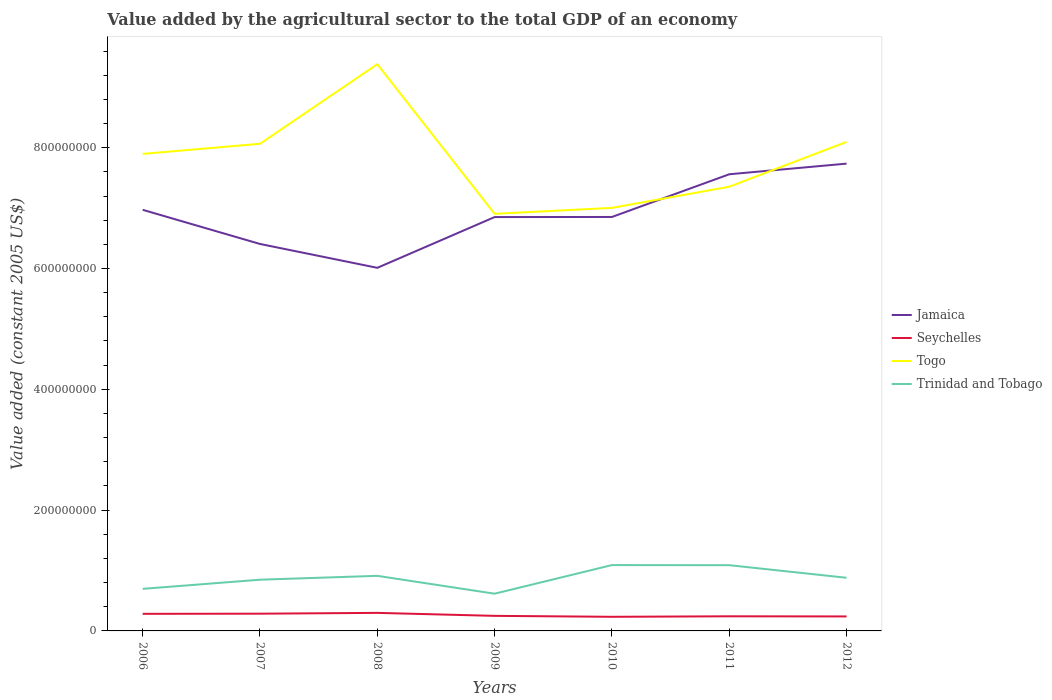How many different coloured lines are there?
Your answer should be very brief. 4. Does the line corresponding to Seychelles intersect with the line corresponding to Jamaica?
Your response must be concise. No. Across all years, what is the maximum value added by the agricultural sector in Trinidad and Tobago?
Your answer should be compact. 6.16e+07. What is the total value added by the agricultural sector in Togo in the graph?
Provide a short and direct response. -1.19e+08. What is the difference between the highest and the second highest value added by the agricultural sector in Jamaica?
Your answer should be very brief. 1.72e+08. What is the difference between the highest and the lowest value added by the agricultural sector in Togo?
Your answer should be very brief. 4. How many lines are there?
Keep it short and to the point. 4. Are the values on the major ticks of Y-axis written in scientific E-notation?
Give a very brief answer. No. Does the graph contain any zero values?
Keep it short and to the point. No. Does the graph contain grids?
Offer a very short reply. No. What is the title of the graph?
Provide a succinct answer. Value added by the agricultural sector to the total GDP of an economy. What is the label or title of the X-axis?
Provide a succinct answer. Years. What is the label or title of the Y-axis?
Your answer should be compact. Value added (constant 2005 US$). What is the Value added (constant 2005 US$) of Jamaica in 2006?
Your answer should be very brief. 6.97e+08. What is the Value added (constant 2005 US$) of Seychelles in 2006?
Offer a terse response. 2.83e+07. What is the Value added (constant 2005 US$) of Togo in 2006?
Your answer should be compact. 7.90e+08. What is the Value added (constant 2005 US$) of Trinidad and Tobago in 2006?
Keep it short and to the point. 6.96e+07. What is the Value added (constant 2005 US$) in Jamaica in 2007?
Give a very brief answer. 6.41e+08. What is the Value added (constant 2005 US$) in Seychelles in 2007?
Your answer should be compact. 2.85e+07. What is the Value added (constant 2005 US$) in Togo in 2007?
Your answer should be very brief. 8.06e+08. What is the Value added (constant 2005 US$) in Trinidad and Tobago in 2007?
Offer a terse response. 8.48e+07. What is the Value added (constant 2005 US$) in Jamaica in 2008?
Provide a short and direct response. 6.01e+08. What is the Value added (constant 2005 US$) in Seychelles in 2008?
Give a very brief answer. 2.99e+07. What is the Value added (constant 2005 US$) in Togo in 2008?
Your response must be concise. 9.38e+08. What is the Value added (constant 2005 US$) in Trinidad and Tobago in 2008?
Your response must be concise. 9.12e+07. What is the Value added (constant 2005 US$) in Jamaica in 2009?
Your response must be concise. 6.85e+08. What is the Value added (constant 2005 US$) of Seychelles in 2009?
Provide a succinct answer. 2.49e+07. What is the Value added (constant 2005 US$) of Togo in 2009?
Your answer should be compact. 6.91e+08. What is the Value added (constant 2005 US$) of Trinidad and Tobago in 2009?
Keep it short and to the point. 6.16e+07. What is the Value added (constant 2005 US$) of Jamaica in 2010?
Your answer should be very brief. 6.85e+08. What is the Value added (constant 2005 US$) in Seychelles in 2010?
Provide a short and direct response. 2.34e+07. What is the Value added (constant 2005 US$) of Togo in 2010?
Your answer should be very brief. 7.00e+08. What is the Value added (constant 2005 US$) of Trinidad and Tobago in 2010?
Your answer should be compact. 1.09e+08. What is the Value added (constant 2005 US$) of Jamaica in 2011?
Your answer should be compact. 7.56e+08. What is the Value added (constant 2005 US$) of Seychelles in 2011?
Your answer should be compact. 2.42e+07. What is the Value added (constant 2005 US$) of Togo in 2011?
Your answer should be compact. 7.35e+08. What is the Value added (constant 2005 US$) in Trinidad and Tobago in 2011?
Your response must be concise. 1.09e+08. What is the Value added (constant 2005 US$) of Jamaica in 2012?
Provide a succinct answer. 7.74e+08. What is the Value added (constant 2005 US$) of Seychelles in 2012?
Provide a short and direct response. 2.40e+07. What is the Value added (constant 2005 US$) in Togo in 2012?
Keep it short and to the point. 8.10e+08. What is the Value added (constant 2005 US$) of Trinidad and Tobago in 2012?
Your answer should be very brief. 8.80e+07. Across all years, what is the maximum Value added (constant 2005 US$) in Jamaica?
Offer a very short reply. 7.74e+08. Across all years, what is the maximum Value added (constant 2005 US$) of Seychelles?
Keep it short and to the point. 2.99e+07. Across all years, what is the maximum Value added (constant 2005 US$) in Togo?
Ensure brevity in your answer.  9.38e+08. Across all years, what is the maximum Value added (constant 2005 US$) of Trinidad and Tobago?
Provide a short and direct response. 1.09e+08. Across all years, what is the minimum Value added (constant 2005 US$) of Jamaica?
Give a very brief answer. 6.01e+08. Across all years, what is the minimum Value added (constant 2005 US$) of Seychelles?
Offer a terse response. 2.34e+07. Across all years, what is the minimum Value added (constant 2005 US$) in Togo?
Offer a very short reply. 6.91e+08. Across all years, what is the minimum Value added (constant 2005 US$) in Trinidad and Tobago?
Provide a succinct answer. 6.16e+07. What is the total Value added (constant 2005 US$) in Jamaica in the graph?
Provide a short and direct response. 4.84e+09. What is the total Value added (constant 2005 US$) of Seychelles in the graph?
Offer a very short reply. 1.83e+08. What is the total Value added (constant 2005 US$) in Togo in the graph?
Provide a succinct answer. 5.47e+09. What is the total Value added (constant 2005 US$) in Trinidad and Tobago in the graph?
Your response must be concise. 6.13e+08. What is the difference between the Value added (constant 2005 US$) of Jamaica in 2006 and that in 2007?
Make the answer very short. 5.65e+07. What is the difference between the Value added (constant 2005 US$) of Seychelles in 2006 and that in 2007?
Offer a terse response. -2.33e+05. What is the difference between the Value added (constant 2005 US$) in Togo in 2006 and that in 2007?
Your response must be concise. -1.67e+07. What is the difference between the Value added (constant 2005 US$) of Trinidad and Tobago in 2006 and that in 2007?
Provide a succinct answer. -1.51e+07. What is the difference between the Value added (constant 2005 US$) in Jamaica in 2006 and that in 2008?
Make the answer very short. 9.60e+07. What is the difference between the Value added (constant 2005 US$) of Seychelles in 2006 and that in 2008?
Keep it short and to the point. -1.56e+06. What is the difference between the Value added (constant 2005 US$) of Togo in 2006 and that in 2008?
Give a very brief answer. -1.49e+08. What is the difference between the Value added (constant 2005 US$) in Trinidad and Tobago in 2006 and that in 2008?
Provide a short and direct response. -2.16e+07. What is the difference between the Value added (constant 2005 US$) of Jamaica in 2006 and that in 2009?
Make the answer very short. 1.20e+07. What is the difference between the Value added (constant 2005 US$) in Seychelles in 2006 and that in 2009?
Your answer should be very brief. 3.37e+06. What is the difference between the Value added (constant 2005 US$) in Togo in 2006 and that in 2009?
Offer a very short reply. 9.92e+07. What is the difference between the Value added (constant 2005 US$) of Trinidad and Tobago in 2006 and that in 2009?
Offer a terse response. 8.02e+06. What is the difference between the Value added (constant 2005 US$) in Jamaica in 2006 and that in 2010?
Give a very brief answer. 1.18e+07. What is the difference between the Value added (constant 2005 US$) of Seychelles in 2006 and that in 2010?
Keep it short and to the point. 4.92e+06. What is the difference between the Value added (constant 2005 US$) of Togo in 2006 and that in 2010?
Make the answer very short. 8.94e+07. What is the difference between the Value added (constant 2005 US$) of Trinidad and Tobago in 2006 and that in 2010?
Give a very brief answer. -3.94e+07. What is the difference between the Value added (constant 2005 US$) of Jamaica in 2006 and that in 2011?
Provide a succinct answer. -5.89e+07. What is the difference between the Value added (constant 2005 US$) in Seychelles in 2006 and that in 2011?
Ensure brevity in your answer.  4.10e+06. What is the difference between the Value added (constant 2005 US$) of Togo in 2006 and that in 2011?
Keep it short and to the point. 5.44e+07. What is the difference between the Value added (constant 2005 US$) in Trinidad and Tobago in 2006 and that in 2011?
Keep it short and to the point. -3.92e+07. What is the difference between the Value added (constant 2005 US$) of Jamaica in 2006 and that in 2012?
Make the answer very short. -7.65e+07. What is the difference between the Value added (constant 2005 US$) in Seychelles in 2006 and that in 2012?
Provide a succinct answer. 4.33e+06. What is the difference between the Value added (constant 2005 US$) in Togo in 2006 and that in 2012?
Your response must be concise. -1.98e+07. What is the difference between the Value added (constant 2005 US$) in Trinidad and Tobago in 2006 and that in 2012?
Make the answer very short. -1.83e+07. What is the difference between the Value added (constant 2005 US$) of Jamaica in 2007 and that in 2008?
Provide a short and direct response. 3.95e+07. What is the difference between the Value added (constant 2005 US$) in Seychelles in 2007 and that in 2008?
Make the answer very short. -1.33e+06. What is the difference between the Value added (constant 2005 US$) in Togo in 2007 and that in 2008?
Offer a very short reply. -1.32e+08. What is the difference between the Value added (constant 2005 US$) in Trinidad and Tobago in 2007 and that in 2008?
Offer a terse response. -6.41e+06. What is the difference between the Value added (constant 2005 US$) of Jamaica in 2007 and that in 2009?
Provide a short and direct response. -4.45e+07. What is the difference between the Value added (constant 2005 US$) of Seychelles in 2007 and that in 2009?
Keep it short and to the point. 3.60e+06. What is the difference between the Value added (constant 2005 US$) in Togo in 2007 and that in 2009?
Your answer should be compact. 1.16e+08. What is the difference between the Value added (constant 2005 US$) of Trinidad and Tobago in 2007 and that in 2009?
Keep it short and to the point. 2.32e+07. What is the difference between the Value added (constant 2005 US$) of Jamaica in 2007 and that in 2010?
Your answer should be very brief. -4.47e+07. What is the difference between the Value added (constant 2005 US$) of Seychelles in 2007 and that in 2010?
Keep it short and to the point. 5.15e+06. What is the difference between the Value added (constant 2005 US$) in Togo in 2007 and that in 2010?
Offer a terse response. 1.06e+08. What is the difference between the Value added (constant 2005 US$) of Trinidad and Tobago in 2007 and that in 2010?
Your answer should be compact. -2.42e+07. What is the difference between the Value added (constant 2005 US$) in Jamaica in 2007 and that in 2011?
Provide a succinct answer. -1.15e+08. What is the difference between the Value added (constant 2005 US$) of Seychelles in 2007 and that in 2011?
Offer a very short reply. 4.33e+06. What is the difference between the Value added (constant 2005 US$) in Togo in 2007 and that in 2011?
Provide a succinct answer. 7.11e+07. What is the difference between the Value added (constant 2005 US$) of Trinidad and Tobago in 2007 and that in 2011?
Provide a succinct answer. -2.40e+07. What is the difference between the Value added (constant 2005 US$) of Jamaica in 2007 and that in 2012?
Provide a short and direct response. -1.33e+08. What is the difference between the Value added (constant 2005 US$) of Seychelles in 2007 and that in 2012?
Ensure brevity in your answer.  4.57e+06. What is the difference between the Value added (constant 2005 US$) of Togo in 2007 and that in 2012?
Provide a short and direct response. -3.08e+06. What is the difference between the Value added (constant 2005 US$) of Trinidad and Tobago in 2007 and that in 2012?
Ensure brevity in your answer.  -3.21e+06. What is the difference between the Value added (constant 2005 US$) of Jamaica in 2008 and that in 2009?
Provide a succinct answer. -8.40e+07. What is the difference between the Value added (constant 2005 US$) in Seychelles in 2008 and that in 2009?
Provide a succinct answer. 4.93e+06. What is the difference between the Value added (constant 2005 US$) in Togo in 2008 and that in 2009?
Provide a succinct answer. 2.48e+08. What is the difference between the Value added (constant 2005 US$) of Trinidad and Tobago in 2008 and that in 2009?
Provide a succinct answer. 2.96e+07. What is the difference between the Value added (constant 2005 US$) in Jamaica in 2008 and that in 2010?
Offer a terse response. -8.42e+07. What is the difference between the Value added (constant 2005 US$) of Seychelles in 2008 and that in 2010?
Make the answer very short. 6.48e+06. What is the difference between the Value added (constant 2005 US$) of Togo in 2008 and that in 2010?
Provide a short and direct response. 2.38e+08. What is the difference between the Value added (constant 2005 US$) of Trinidad and Tobago in 2008 and that in 2010?
Keep it short and to the point. -1.78e+07. What is the difference between the Value added (constant 2005 US$) in Jamaica in 2008 and that in 2011?
Keep it short and to the point. -1.55e+08. What is the difference between the Value added (constant 2005 US$) of Seychelles in 2008 and that in 2011?
Make the answer very short. 5.66e+06. What is the difference between the Value added (constant 2005 US$) of Togo in 2008 and that in 2011?
Keep it short and to the point. 2.03e+08. What is the difference between the Value added (constant 2005 US$) in Trinidad and Tobago in 2008 and that in 2011?
Make the answer very short. -1.76e+07. What is the difference between the Value added (constant 2005 US$) of Jamaica in 2008 and that in 2012?
Provide a succinct answer. -1.72e+08. What is the difference between the Value added (constant 2005 US$) of Seychelles in 2008 and that in 2012?
Provide a short and direct response. 5.89e+06. What is the difference between the Value added (constant 2005 US$) in Togo in 2008 and that in 2012?
Your answer should be very brief. 1.29e+08. What is the difference between the Value added (constant 2005 US$) in Trinidad and Tobago in 2008 and that in 2012?
Your answer should be compact. 3.21e+06. What is the difference between the Value added (constant 2005 US$) of Jamaica in 2009 and that in 2010?
Your answer should be very brief. -1.57e+05. What is the difference between the Value added (constant 2005 US$) in Seychelles in 2009 and that in 2010?
Give a very brief answer. 1.55e+06. What is the difference between the Value added (constant 2005 US$) in Togo in 2009 and that in 2010?
Offer a terse response. -9.86e+06. What is the difference between the Value added (constant 2005 US$) of Trinidad and Tobago in 2009 and that in 2010?
Offer a very short reply. -4.74e+07. What is the difference between the Value added (constant 2005 US$) in Jamaica in 2009 and that in 2011?
Offer a very short reply. -7.09e+07. What is the difference between the Value added (constant 2005 US$) of Seychelles in 2009 and that in 2011?
Make the answer very short. 7.29e+05. What is the difference between the Value added (constant 2005 US$) of Togo in 2009 and that in 2011?
Keep it short and to the point. -4.48e+07. What is the difference between the Value added (constant 2005 US$) of Trinidad and Tobago in 2009 and that in 2011?
Provide a succinct answer. -4.72e+07. What is the difference between the Value added (constant 2005 US$) in Jamaica in 2009 and that in 2012?
Provide a succinct answer. -8.85e+07. What is the difference between the Value added (constant 2005 US$) in Seychelles in 2009 and that in 2012?
Ensure brevity in your answer.  9.67e+05. What is the difference between the Value added (constant 2005 US$) of Togo in 2009 and that in 2012?
Provide a succinct answer. -1.19e+08. What is the difference between the Value added (constant 2005 US$) in Trinidad and Tobago in 2009 and that in 2012?
Provide a succinct answer. -2.64e+07. What is the difference between the Value added (constant 2005 US$) in Jamaica in 2010 and that in 2011?
Your answer should be compact. -7.07e+07. What is the difference between the Value added (constant 2005 US$) of Seychelles in 2010 and that in 2011?
Offer a terse response. -8.21e+05. What is the difference between the Value added (constant 2005 US$) in Togo in 2010 and that in 2011?
Your answer should be very brief. -3.50e+07. What is the difference between the Value added (constant 2005 US$) in Trinidad and Tobago in 2010 and that in 2011?
Make the answer very short. 1.78e+05. What is the difference between the Value added (constant 2005 US$) of Jamaica in 2010 and that in 2012?
Offer a terse response. -8.83e+07. What is the difference between the Value added (constant 2005 US$) of Seychelles in 2010 and that in 2012?
Give a very brief answer. -5.84e+05. What is the difference between the Value added (constant 2005 US$) in Togo in 2010 and that in 2012?
Provide a short and direct response. -1.09e+08. What is the difference between the Value added (constant 2005 US$) of Trinidad and Tobago in 2010 and that in 2012?
Your response must be concise. 2.10e+07. What is the difference between the Value added (constant 2005 US$) of Jamaica in 2011 and that in 2012?
Ensure brevity in your answer.  -1.76e+07. What is the difference between the Value added (constant 2005 US$) in Seychelles in 2011 and that in 2012?
Keep it short and to the point. 2.37e+05. What is the difference between the Value added (constant 2005 US$) of Togo in 2011 and that in 2012?
Your answer should be very brief. -7.42e+07. What is the difference between the Value added (constant 2005 US$) of Trinidad and Tobago in 2011 and that in 2012?
Make the answer very short. 2.08e+07. What is the difference between the Value added (constant 2005 US$) in Jamaica in 2006 and the Value added (constant 2005 US$) in Seychelles in 2007?
Make the answer very short. 6.69e+08. What is the difference between the Value added (constant 2005 US$) in Jamaica in 2006 and the Value added (constant 2005 US$) in Togo in 2007?
Ensure brevity in your answer.  -1.09e+08. What is the difference between the Value added (constant 2005 US$) in Jamaica in 2006 and the Value added (constant 2005 US$) in Trinidad and Tobago in 2007?
Offer a terse response. 6.12e+08. What is the difference between the Value added (constant 2005 US$) in Seychelles in 2006 and the Value added (constant 2005 US$) in Togo in 2007?
Make the answer very short. -7.78e+08. What is the difference between the Value added (constant 2005 US$) of Seychelles in 2006 and the Value added (constant 2005 US$) of Trinidad and Tobago in 2007?
Ensure brevity in your answer.  -5.65e+07. What is the difference between the Value added (constant 2005 US$) in Togo in 2006 and the Value added (constant 2005 US$) in Trinidad and Tobago in 2007?
Your answer should be compact. 7.05e+08. What is the difference between the Value added (constant 2005 US$) of Jamaica in 2006 and the Value added (constant 2005 US$) of Seychelles in 2008?
Your answer should be compact. 6.67e+08. What is the difference between the Value added (constant 2005 US$) of Jamaica in 2006 and the Value added (constant 2005 US$) of Togo in 2008?
Provide a succinct answer. -2.41e+08. What is the difference between the Value added (constant 2005 US$) in Jamaica in 2006 and the Value added (constant 2005 US$) in Trinidad and Tobago in 2008?
Provide a short and direct response. 6.06e+08. What is the difference between the Value added (constant 2005 US$) of Seychelles in 2006 and the Value added (constant 2005 US$) of Togo in 2008?
Your answer should be very brief. -9.10e+08. What is the difference between the Value added (constant 2005 US$) in Seychelles in 2006 and the Value added (constant 2005 US$) in Trinidad and Tobago in 2008?
Provide a short and direct response. -6.29e+07. What is the difference between the Value added (constant 2005 US$) in Togo in 2006 and the Value added (constant 2005 US$) in Trinidad and Tobago in 2008?
Ensure brevity in your answer.  6.99e+08. What is the difference between the Value added (constant 2005 US$) in Jamaica in 2006 and the Value added (constant 2005 US$) in Seychelles in 2009?
Your response must be concise. 6.72e+08. What is the difference between the Value added (constant 2005 US$) of Jamaica in 2006 and the Value added (constant 2005 US$) of Togo in 2009?
Provide a short and direct response. 6.63e+06. What is the difference between the Value added (constant 2005 US$) in Jamaica in 2006 and the Value added (constant 2005 US$) in Trinidad and Tobago in 2009?
Your response must be concise. 6.36e+08. What is the difference between the Value added (constant 2005 US$) in Seychelles in 2006 and the Value added (constant 2005 US$) in Togo in 2009?
Keep it short and to the point. -6.62e+08. What is the difference between the Value added (constant 2005 US$) of Seychelles in 2006 and the Value added (constant 2005 US$) of Trinidad and Tobago in 2009?
Your response must be concise. -3.33e+07. What is the difference between the Value added (constant 2005 US$) in Togo in 2006 and the Value added (constant 2005 US$) in Trinidad and Tobago in 2009?
Your answer should be very brief. 7.28e+08. What is the difference between the Value added (constant 2005 US$) of Jamaica in 2006 and the Value added (constant 2005 US$) of Seychelles in 2010?
Give a very brief answer. 6.74e+08. What is the difference between the Value added (constant 2005 US$) in Jamaica in 2006 and the Value added (constant 2005 US$) in Togo in 2010?
Your response must be concise. -3.22e+06. What is the difference between the Value added (constant 2005 US$) of Jamaica in 2006 and the Value added (constant 2005 US$) of Trinidad and Tobago in 2010?
Your answer should be very brief. 5.88e+08. What is the difference between the Value added (constant 2005 US$) of Seychelles in 2006 and the Value added (constant 2005 US$) of Togo in 2010?
Ensure brevity in your answer.  -6.72e+08. What is the difference between the Value added (constant 2005 US$) in Seychelles in 2006 and the Value added (constant 2005 US$) in Trinidad and Tobago in 2010?
Provide a short and direct response. -8.07e+07. What is the difference between the Value added (constant 2005 US$) of Togo in 2006 and the Value added (constant 2005 US$) of Trinidad and Tobago in 2010?
Offer a terse response. 6.81e+08. What is the difference between the Value added (constant 2005 US$) in Jamaica in 2006 and the Value added (constant 2005 US$) in Seychelles in 2011?
Your answer should be very brief. 6.73e+08. What is the difference between the Value added (constant 2005 US$) in Jamaica in 2006 and the Value added (constant 2005 US$) in Togo in 2011?
Your response must be concise. -3.82e+07. What is the difference between the Value added (constant 2005 US$) of Jamaica in 2006 and the Value added (constant 2005 US$) of Trinidad and Tobago in 2011?
Provide a succinct answer. 5.88e+08. What is the difference between the Value added (constant 2005 US$) of Seychelles in 2006 and the Value added (constant 2005 US$) of Togo in 2011?
Provide a succinct answer. -7.07e+08. What is the difference between the Value added (constant 2005 US$) of Seychelles in 2006 and the Value added (constant 2005 US$) of Trinidad and Tobago in 2011?
Provide a succinct answer. -8.05e+07. What is the difference between the Value added (constant 2005 US$) of Togo in 2006 and the Value added (constant 2005 US$) of Trinidad and Tobago in 2011?
Provide a succinct answer. 6.81e+08. What is the difference between the Value added (constant 2005 US$) of Jamaica in 2006 and the Value added (constant 2005 US$) of Seychelles in 2012?
Provide a succinct answer. 6.73e+08. What is the difference between the Value added (constant 2005 US$) of Jamaica in 2006 and the Value added (constant 2005 US$) of Togo in 2012?
Give a very brief answer. -1.12e+08. What is the difference between the Value added (constant 2005 US$) in Jamaica in 2006 and the Value added (constant 2005 US$) in Trinidad and Tobago in 2012?
Your response must be concise. 6.09e+08. What is the difference between the Value added (constant 2005 US$) of Seychelles in 2006 and the Value added (constant 2005 US$) of Togo in 2012?
Provide a succinct answer. -7.81e+08. What is the difference between the Value added (constant 2005 US$) of Seychelles in 2006 and the Value added (constant 2005 US$) of Trinidad and Tobago in 2012?
Your answer should be compact. -5.97e+07. What is the difference between the Value added (constant 2005 US$) of Togo in 2006 and the Value added (constant 2005 US$) of Trinidad and Tobago in 2012?
Provide a short and direct response. 7.02e+08. What is the difference between the Value added (constant 2005 US$) of Jamaica in 2007 and the Value added (constant 2005 US$) of Seychelles in 2008?
Your answer should be very brief. 6.11e+08. What is the difference between the Value added (constant 2005 US$) in Jamaica in 2007 and the Value added (constant 2005 US$) in Togo in 2008?
Your response must be concise. -2.98e+08. What is the difference between the Value added (constant 2005 US$) of Jamaica in 2007 and the Value added (constant 2005 US$) of Trinidad and Tobago in 2008?
Your answer should be compact. 5.49e+08. What is the difference between the Value added (constant 2005 US$) in Seychelles in 2007 and the Value added (constant 2005 US$) in Togo in 2008?
Offer a very short reply. -9.10e+08. What is the difference between the Value added (constant 2005 US$) in Seychelles in 2007 and the Value added (constant 2005 US$) in Trinidad and Tobago in 2008?
Provide a short and direct response. -6.27e+07. What is the difference between the Value added (constant 2005 US$) of Togo in 2007 and the Value added (constant 2005 US$) of Trinidad and Tobago in 2008?
Provide a succinct answer. 7.15e+08. What is the difference between the Value added (constant 2005 US$) of Jamaica in 2007 and the Value added (constant 2005 US$) of Seychelles in 2009?
Make the answer very short. 6.16e+08. What is the difference between the Value added (constant 2005 US$) of Jamaica in 2007 and the Value added (constant 2005 US$) of Togo in 2009?
Provide a short and direct response. -4.99e+07. What is the difference between the Value added (constant 2005 US$) in Jamaica in 2007 and the Value added (constant 2005 US$) in Trinidad and Tobago in 2009?
Provide a succinct answer. 5.79e+08. What is the difference between the Value added (constant 2005 US$) in Seychelles in 2007 and the Value added (constant 2005 US$) in Togo in 2009?
Your answer should be very brief. -6.62e+08. What is the difference between the Value added (constant 2005 US$) of Seychelles in 2007 and the Value added (constant 2005 US$) of Trinidad and Tobago in 2009?
Provide a short and direct response. -3.31e+07. What is the difference between the Value added (constant 2005 US$) in Togo in 2007 and the Value added (constant 2005 US$) in Trinidad and Tobago in 2009?
Provide a succinct answer. 7.45e+08. What is the difference between the Value added (constant 2005 US$) of Jamaica in 2007 and the Value added (constant 2005 US$) of Seychelles in 2010?
Your answer should be very brief. 6.17e+08. What is the difference between the Value added (constant 2005 US$) of Jamaica in 2007 and the Value added (constant 2005 US$) of Togo in 2010?
Ensure brevity in your answer.  -5.97e+07. What is the difference between the Value added (constant 2005 US$) in Jamaica in 2007 and the Value added (constant 2005 US$) in Trinidad and Tobago in 2010?
Offer a terse response. 5.32e+08. What is the difference between the Value added (constant 2005 US$) of Seychelles in 2007 and the Value added (constant 2005 US$) of Togo in 2010?
Provide a succinct answer. -6.72e+08. What is the difference between the Value added (constant 2005 US$) of Seychelles in 2007 and the Value added (constant 2005 US$) of Trinidad and Tobago in 2010?
Provide a short and direct response. -8.05e+07. What is the difference between the Value added (constant 2005 US$) of Togo in 2007 and the Value added (constant 2005 US$) of Trinidad and Tobago in 2010?
Offer a very short reply. 6.97e+08. What is the difference between the Value added (constant 2005 US$) of Jamaica in 2007 and the Value added (constant 2005 US$) of Seychelles in 2011?
Your answer should be very brief. 6.16e+08. What is the difference between the Value added (constant 2005 US$) of Jamaica in 2007 and the Value added (constant 2005 US$) of Togo in 2011?
Your response must be concise. -9.47e+07. What is the difference between the Value added (constant 2005 US$) in Jamaica in 2007 and the Value added (constant 2005 US$) in Trinidad and Tobago in 2011?
Your answer should be compact. 5.32e+08. What is the difference between the Value added (constant 2005 US$) in Seychelles in 2007 and the Value added (constant 2005 US$) in Togo in 2011?
Give a very brief answer. -7.07e+08. What is the difference between the Value added (constant 2005 US$) in Seychelles in 2007 and the Value added (constant 2005 US$) in Trinidad and Tobago in 2011?
Provide a succinct answer. -8.03e+07. What is the difference between the Value added (constant 2005 US$) in Togo in 2007 and the Value added (constant 2005 US$) in Trinidad and Tobago in 2011?
Make the answer very short. 6.98e+08. What is the difference between the Value added (constant 2005 US$) in Jamaica in 2007 and the Value added (constant 2005 US$) in Seychelles in 2012?
Offer a very short reply. 6.17e+08. What is the difference between the Value added (constant 2005 US$) in Jamaica in 2007 and the Value added (constant 2005 US$) in Togo in 2012?
Ensure brevity in your answer.  -1.69e+08. What is the difference between the Value added (constant 2005 US$) in Jamaica in 2007 and the Value added (constant 2005 US$) in Trinidad and Tobago in 2012?
Offer a very short reply. 5.53e+08. What is the difference between the Value added (constant 2005 US$) in Seychelles in 2007 and the Value added (constant 2005 US$) in Togo in 2012?
Your answer should be very brief. -7.81e+08. What is the difference between the Value added (constant 2005 US$) of Seychelles in 2007 and the Value added (constant 2005 US$) of Trinidad and Tobago in 2012?
Your answer should be very brief. -5.94e+07. What is the difference between the Value added (constant 2005 US$) in Togo in 2007 and the Value added (constant 2005 US$) in Trinidad and Tobago in 2012?
Your answer should be compact. 7.18e+08. What is the difference between the Value added (constant 2005 US$) in Jamaica in 2008 and the Value added (constant 2005 US$) in Seychelles in 2009?
Make the answer very short. 5.76e+08. What is the difference between the Value added (constant 2005 US$) of Jamaica in 2008 and the Value added (constant 2005 US$) of Togo in 2009?
Give a very brief answer. -8.94e+07. What is the difference between the Value added (constant 2005 US$) in Jamaica in 2008 and the Value added (constant 2005 US$) in Trinidad and Tobago in 2009?
Give a very brief answer. 5.40e+08. What is the difference between the Value added (constant 2005 US$) in Seychelles in 2008 and the Value added (constant 2005 US$) in Togo in 2009?
Offer a very short reply. -6.61e+08. What is the difference between the Value added (constant 2005 US$) in Seychelles in 2008 and the Value added (constant 2005 US$) in Trinidad and Tobago in 2009?
Provide a succinct answer. -3.18e+07. What is the difference between the Value added (constant 2005 US$) of Togo in 2008 and the Value added (constant 2005 US$) of Trinidad and Tobago in 2009?
Your answer should be compact. 8.77e+08. What is the difference between the Value added (constant 2005 US$) of Jamaica in 2008 and the Value added (constant 2005 US$) of Seychelles in 2010?
Ensure brevity in your answer.  5.78e+08. What is the difference between the Value added (constant 2005 US$) of Jamaica in 2008 and the Value added (constant 2005 US$) of Togo in 2010?
Give a very brief answer. -9.92e+07. What is the difference between the Value added (constant 2005 US$) of Jamaica in 2008 and the Value added (constant 2005 US$) of Trinidad and Tobago in 2010?
Your answer should be very brief. 4.92e+08. What is the difference between the Value added (constant 2005 US$) in Seychelles in 2008 and the Value added (constant 2005 US$) in Togo in 2010?
Ensure brevity in your answer.  -6.71e+08. What is the difference between the Value added (constant 2005 US$) in Seychelles in 2008 and the Value added (constant 2005 US$) in Trinidad and Tobago in 2010?
Provide a short and direct response. -7.91e+07. What is the difference between the Value added (constant 2005 US$) of Togo in 2008 and the Value added (constant 2005 US$) of Trinidad and Tobago in 2010?
Make the answer very short. 8.29e+08. What is the difference between the Value added (constant 2005 US$) of Jamaica in 2008 and the Value added (constant 2005 US$) of Seychelles in 2011?
Provide a short and direct response. 5.77e+08. What is the difference between the Value added (constant 2005 US$) in Jamaica in 2008 and the Value added (constant 2005 US$) in Togo in 2011?
Your response must be concise. -1.34e+08. What is the difference between the Value added (constant 2005 US$) of Jamaica in 2008 and the Value added (constant 2005 US$) of Trinidad and Tobago in 2011?
Provide a short and direct response. 4.92e+08. What is the difference between the Value added (constant 2005 US$) in Seychelles in 2008 and the Value added (constant 2005 US$) in Togo in 2011?
Give a very brief answer. -7.06e+08. What is the difference between the Value added (constant 2005 US$) in Seychelles in 2008 and the Value added (constant 2005 US$) in Trinidad and Tobago in 2011?
Offer a terse response. -7.90e+07. What is the difference between the Value added (constant 2005 US$) of Togo in 2008 and the Value added (constant 2005 US$) of Trinidad and Tobago in 2011?
Your response must be concise. 8.29e+08. What is the difference between the Value added (constant 2005 US$) of Jamaica in 2008 and the Value added (constant 2005 US$) of Seychelles in 2012?
Offer a terse response. 5.77e+08. What is the difference between the Value added (constant 2005 US$) in Jamaica in 2008 and the Value added (constant 2005 US$) in Togo in 2012?
Your response must be concise. -2.08e+08. What is the difference between the Value added (constant 2005 US$) of Jamaica in 2008 and the Value added (constant 2005 US$) of Trinidad and Tobago in 2012?
Your response must be concise. 5.13e+08. What is the difference between the Value added (constant 2005 US$) in Seychelles in 2008 and the Value added (constant 2005 US$) in Togo in 2012?
Keep it short and to the point. -7.80e+08. What is the difference between the Value added (constant 2005 US$) of Seychelles in 2008 and the Value added (constant 2005 US$) of Trinidad and Tobago in 2012?
Offer a very short reply. -5.81e+07. What is the difference between the Value added (constant 2005 US$) in Togo in 2008 and the Value added (constant 2005 US$) in Trinidad and Tobago in 2012?
Offer a terse response. 8.50e+08. What is the difference between the Value added (constant 2005 US$) in Jamaica in 2009 and the Value added (constant 2005 US$) in Seychelles in 2010?
Keep it short and to the point. 6.62e+08. What is the difference between the Value added (constant 2005 US$) of Jamaica in 2009 and the Value added (constant 2005 US$) of Togo in 2010?
Provide a succinct answer. -1.52e+07. What is the difference between the Value added (constant 2005 US$) in Jamaica in 2009 and the Value added (constant 2005 US$) in Trinidad and Tobago in 2010?
Your response must be concise. 5.76e+08. What is the difference between the Value added (constant 2005 US$) of Seychelles in 2009 and the Value added (constant 2005 US$) of Togo in 2010?
Your response must be concise. -6.75e+08. What is the difference between the Value added (constant 2005 US$) in Seychelles in 2009 and the Value added (constant 2005 US$) in Trinidad and Tobago in 2010?
Ensure brevity in your answer.  -8.41e+07. What is the difference between the Value added (constant 2005 US$) of Togo in 2009 and the Value added (constant 2005 US$) of Trinidad and Tobago in 2010?
Ensure brevity in your answer.  5.82e+08. What is the difference between the Value added (constant 2005 US$) in Jamaica in 2009 and the Value added (constant 2005 US$) in Seychelles in 2011?
Ensure brevity in your answer.  6.61e+08. What is the difference between the Value added (constant 2005 US$) in Jamaica in 2009 and the Value added (constant 2005 US$) in Togo in 2011?
Ensure brevity in your answer.  -5.02e+07. What is the difference between the Value added (constant 2005 US$) of Jamaica in 2009 and the Value added (constant 2005 US$) of Trinidad and Tobago in 2011?
Your answer should be very brief. 5.76e+08. What is the difference between the Value added (constant 2005 US$) of Seychelles in 2009 and the Value added (constant 2005 US$) of Togo in 2011?
Make the answer very short. -7.10e+08. What is the difference between the Value added (constant 2005 US$) in Seychelles in 2009 and the Value added (constant 2005 US$) in Trinidad and Tobago in 2011?
Ensure brevity in your answer.  -8.39e+07. What is the difference between the Value added (constant 2005 US$) in Togo in 2009 and the Value added (constant 2005 US$) in Trinidad and Tobago in 2011?
Provide a short and direct response. 5.82e+08. What is the difference between the Value added (constant 2005 US$) of Jamaica in 2009 and the Value added (constant 2005 US$) of Seychelles in 2012?
Give a very brief answer. 6.61e+08. What is the difference between the Value added (constant 2005 US$) in Jamaica in 2009 and the Value added (constant 2005 US$) in Togo in 2012?
Your response must be concise. -1.24e+08. What is the difference between the Value added (constant 2005 US$) of Jamaica in 2009 and the Value added (constant 2005 US$) of Trinidad and Tobago in 2012?
Your answer should be compact. 5.97e+08. What is the difference between the Value added (constant 2005 US$) of Seychelles in 2009 and the Value added (constant 2005 US$) of Togo in 2012?
Provide a succinct answer. -7.85e+08. What is the difference between the Value added (constant 2005 US$) of Seychelles in 2009 and the Value added (constant 2005 US$) of Trinidad and Tobago in 2012?
Give a very brief answer. -6.30e+07. What is the difference between the Value added (constant 2005 US$) of Togo in 2009 and the Value added (constant 2005 US$) of Trinidad and Tobago in 2012?
Keep it short and to the point. 6.03e+08. What is the difference between the Value added (constant 2005 US$) in Jamaica in 2010 and the Value added (constant 2005 US$) in Seychelles in 2011?
Keep it short and to the point. 6.61e+08. What is the difference between the Value added (constant 2005 US$) of Jamaica in 2010 and the Value added (constant 2005 US$) of Togo in 2011?
Your answer should be compact. -5.00e+07. What is the difference between the Value added (constant 2005 US$) in Jamaica in 2010 and the Value added (constant 2005 US$) in Trinidad and Tobago in 2011?
Your answer should be very brief. 5.76e+08. What is the difference between the Value added (constant 2005 US$) of Seychelles in 2010 and the Value added (constant 2005 US$) of Togo in 2011?
Your answer should be compact. -7.12e+08. What is the difference between the Value added (constant 2005 US$) of Seychelles in 2010 and the Value added (constant 2005 US$) of Trinidad and Tobago in 2011?
Ensure brevity in your answer.  -8.54e+07. What is the difference between the Value added (constant 2005 US$) in Togo in 2010 and the Value added (constant 2005 US$) in Trinidad and Tobago in 2011?
Make the answer very short. 5.92e+08. What is the difference between the Value added (constant 2005 US$) of Jamaica in 2010 and the Value added (constant 2005 US$) of Seychelles in 2012?
Your answer should be very brief. 6.61e+08. What is the difference between the Value added (constant 2005 US$) in Jamaica in 2010 and the Value added (constant 2005 US$) in Togo in 2012?
Provide a short and direct response. -1.24e+08. What is the difference between the Value added (constant 2005 US$) of Jamaica in 2010 and the Value added (constant 2005 US$) of Trinidad and Tobago in 2012?
Keep it short and to the point. 5.97e+08. What is the difference between the Value added (constant 2005 US$) in Seychelles in 2010 and the Value added (constant 2005 US$) in Togo in 2012?
Your answer should be compact. -7.86e+08. What is the difference between the Value added (constant 2005 US$) of Seychelles in 2010 and the Value added (constant 2005 US$) of Trinidad and Tobago in 2012?
Your answer should be very brief. -6.46e+07. What is the difference between the Value added (constant 2005 US$) of Togo in 2010 and the Value added (constant 2005 US$) of Trinidad and Tobago in 2012?
Your answer should be compact. 6.12e+08. What is the difference between the Value added (constant 2005 US$) in Jamaica in 2011 and the Value added (constant 2005 US$) in Seychelles in 2012?
Offer a terse response. 7.32e+08. What is the difference between the Value added (constant 2005 US$) of Jamaica in 2011 and the Value added (constant 2005 US$) of Togo in 2012?
Keep it short and to the point. -5.35e+07. What is the difference between the Value added (constant 2005 US$) in Jamaica in 2011 and the Value added (constant 2005 US$) in Trinidad and Tobago in 2012?
Offer a very short reply. 6.68e+08. What is the difference between the Value added (constant 2005 US$) of Seychelles in 2011 and the Value added (constant 2005 US$) of Togo in 2012?
Make the answer very short. -7.85e+08. What is the difference between the Value added (constant 2005 US$) in Seychelles in 2011 and the Value added (constant 2005 US$) in Trinidad and Tobago in 2012?
Ensure brevity in your answer.  -6.38e+07. What is the difference between the Value added (constant 2005 US$) of Togo in 2011 and the Value added (constant 2005 US$) of Trinidad and Tobago in 2012?
Your response must be concise. 6.47e+08. What is the average Value added (constant 2005 US$) in Jamaica per year?
Your answer should be compact. 6.91e+08. What is the average Value added (constant 2005 US$) in Seychelles per year?
Offer a terse response. 2.62e+07. What is the average Value added (constant 2005 US$) in Togo per year?
Give a very brief answer. 7.81e+08. What is the average Value added (constant 2005 US$) of Trinidad and Tobago per year?
Keep it short and to the point. 8.76e+07. In the year 2006, what is the difference between the Value added (constant 2005 US$) of Jamaica and Value added (constant 2005 US$) of Seychelles?
Ensure brevity in your answer.  6.69e+08. In the year 2006, what is the difference between the Value added (constant 2005 US$) of Jamaica and Value added (constant 2005 US$) of Togo?
Ensure brevity in your answer.  -9.26e+07. In the year 2006, what is the difference between the Value added (constant 2005 US$) of Jamaica and Value added (constant 2005 US$) of Trinidad and Tobago?
Offer a very short reply. 6.28e+08. In the year 2006, what is the difference between the Value added (constant 2005 US$) in Seychelles and Value added (constant 2005 US$) in Togo?
Make the answer very short. -7.61e+08. In the year 2006, what is the difference between the Value added (constant 2005 US$) of Seychelles and Value added (constant 2005 US$) of Trinidad and Tobago?
Make the answer very short. -4.13e+07. In the year 2006, what is the difference between the Value added (constant 2005 US$) in Togo and Value added (constant 2005 US$) in Trinidad and Tobago?
Your response must be concise. 7.20e+08. In the year 2007, what is the difference between the Value added (constant 2005 US$) of Jamaica and Value added (constant 2005 US$) of Seychelles?
Offer a terse response. 6.12e+08. In the year 2007, what is the difference between the Value added (constant 2005 US$) in Jamaica and Value added (constant 2005 US$) in Togo?
Offer a very short reply. -1.66e+08. In the year 2007, what is the difference between the Value added (constant 2005 US$) of Jamaica and Value added (constant 2005 US$) of Trinidad and Tobago?
Keep it short and to the point. 5.56e+08. In the year 2007, what is the difference between the Value added (constant 2005 US$) in Seychelles and Value added (constant 2005 US$) in Togo?
Keep it short and to the point. -7.78e+08. In the year 2007, what is the difference between the Value added (constant 2005 US$) in Seychelles and Value added (constant 2005 US$) in Trinidad and Tobago?
Your answer should be very brief. -5.62e+07. In the year 2007, what is the difference between the Value added (constant 2005 US$) of Togo and Value added (constant 2005 US$) of Trinidad and Tobago?
Make the answer very short. 7.22e+08. In the year 2008, what is the difference between the Value added (constant 2005 US$) in Jamaica and Value added (constant 2005 US$) in Seychelles?
Offer a very short reply. 5.71e+08. In the year 2008, what is the difference between the Value added (constant 2005 US$) of Jamaica and Value added (constant 2005 US$) of Togo?
Offer a very short reply. -3.37e+08. In the year 2008, what is the difference between the Value added (constant 2005 US$) in Jamaica and Value added (constant 2005 US$) in Trinidad and Tobago?
Provide a short and direct response. 5.10e+08. In the year 2008, what is the difference between the Value added (constant 2005 US$) in Seychelles and Value added (constant 2005 US$) in Togo?
Provide a short and direct response. -9.08e+08. In the year 2008, what is the difference between the Value added (constant 2005 US$) of Seychelles and Value added (constant 2005 US$) of Trinidad and Tobago?
Provide a succinct answer. -6.13e+07. In the year 2008, what is the difference between the Value added (constant 2005 US$) in Togo and Value added (constant 2005 US$) in Trinidad and Tobago?
Ensure brevity in your answer.  8.47e+08. In the year 2009, what is the difference between the Value added (constant 2005 US$) of Jamaica and Value added (constant 2005 US$) of Seychelles?
Keep it short and to the point. 6.60e+08. In the year 2009, what is the difference between the Value added (constant 2005 US$) of Jamaica and Value added (constant 2005 US$) of Togo?
Ensure brevity in your answer.  -5.36e+06. In the year 2009, what is the difference between the Value added (constant 2005 US$) of Jamaica and Value added (constant 2005 US$) of Trinidad and Tobago?
Ensure brevity in your answer.  6.24e+08. In the year 2009, what is the difference between the Value added (constant 2005 US$) of Seychelles and Value added (constant 2005 US$) of Togo?
Offer a terse response. -6.66e+08. In the year 2009, what is the difference between the Value added (constant 2005 US$) of Seychelles and Value added (constant 2005 US$) of Trinidad and Tobago?
Your response must be concise. -3.67e+07. In the year 2009, what is the difference between the Value added (constant 2005 US$) of Togo and Value added (constant 2005 US$) of Trinidad and Tobago?
Offer a very short reply. 6.29e+08. In the year 2010, what is the difference between the Value added (constant 2005 US$) of Jamaica and Value added (constant 2005 US$) of Seychelles?
Make the answer very short. 6.62e+08. In the year 2010, what is the difference between the Value added (constant 2005 US$) in Jamaica and Value added (constant 2005 US$) in Togo?
Provide a short and direct response. -1.51e+07. In the year 2010, what is the difference between the Value added (constant 2005 US$) in Jamaica and Value added (constant 2005 US$) in Trinidad and Tobago?
Your answer should be very brief. 5.76e+08. In the year 2010, what is the difference between the Value added (constant 2005 US$) in Seychelles and Value added (constant 2005 US$) in Togo?
Offer a terse response. -6.77e+08. In the year 2010, what is the difference between the Value added (constant 2005 US$) of Seychelles and Value added (constant 2005 US$) of Trinidad and Tobago?
Provide a short and direct response. -8.56e+07. In the year 2010, what is the difference between the Value added (constant 2005 US$) of Togo and Value added (constant 2005 US$) of Trinidad and Tobago?
Provide a short and direct response. 5.91e+08. In the year 2011, what is the difference between the Value added (constant 2005 US$) in Jamaica and Value added (constant 2005 US$) in Seychelles?
Offer a terse response. 7.32e+08. In the year 2011, what is the difference between the Value added (constant 2005 US$) of Jamaica and Value added (constant 2005 US$) of Togo?
Your answer should be very brief. 2.07e+07. In the year 2011, what is the difference between the Value added (constant 2005 US$) of Jamaica and Value added (constant 2005 US$) of Trinidad and Tobago?
Give a very brief answer. 6.47e+08. In the year 2011, what is the difference between the Value added (constant 2005 US$) of Seychelles and Value added (constant 2005 US$) of Togo?
Your response must be concise. -7.11e+08. In the year 2011, what is the difference between the Value added (constant 2005 US$) of Seychelles and Value added (constant 2005 US$) of Trinidad and Tobago?
Ensure brevity in your answer.  -8.46e+07. In the year 2011, what is the difference between the Value added (constant 2005 US$) in Togo and Value added (constant 2005 US$) in Trinidad and Tobago?
Give a very brief answer. 6.27e+08. In the year 2012, what is the difference between the Value added (constant 2005 US$) of Jamaica and Value added (constant 2005 US$) of Seychelles?
Make the answer very short. 7.50e+08. In the year 2012, what is the difference between the Value added (constant 2005 US$) of Jamaica and Value added (constant 2005 US$) of Togo?
Keep it short and to the point. -3.59e+07. In the year 2012, what is the difference between the Value added (constant 2005 US$) in Jamaica and Value added (constant 2005 US$) in Trinidad and Tobago?
Your answer should be compact. 6.86e+08. In the year 2012, what is the difference between the Value added (constant 2005 US$) of Seychelles and Value added (constant 2005 US$) of Togo?
Ensure brevity in your answer.  -7.86e+08. In the year 2012, what is the difference between the Value added (constant 2005 US$) in Seychelles and Value added (constant 2005 US$) in Trinidad and Tobago?
Offer a very short reply. -6.40e+07. In the year 2012, what is the difference between the Value added (constant 2005 US$) of Togo and Value added (constant 2005 US$) of Trinidad and Tobago?
Keep it short and to the point. 7.22e+08. What is the ratio of the Value added (constant 2005 US$) of Jamaica in 2006 to that in 2007?
Keep it short and to the point. 1.09. What is the ratio of the Value added (constant 2005 US$) in Togo in 2006 to that in 2007?
Your answer should be very brief. 0.98. What is the ratio of the Value added (constant 2005 US$) of Trinidad and Tobago in 2006 to that in 2007?
Your answer should be compact. 0.82. What is the ratio of the Value added (constant 2005 US$) of Jamaica in 2006 to that in 2008?
Make the answer very short. 1.16. What is the ratio of the Value added (constant 2005 US$) of Seychelles in 2006 to that in 2008?
Offer a very short reply. 0.95. What is the ratio of the Value added (constant 2005 US$) of Togo in 2006 to that in 2008?
Your answer should be compact. 0.84. What is the ratio of the Value added (constant 2005 US$) in Trinidad and Tobago in 2006 to that in 2008?
Make the answer very short. 0.76. What is the ratio of the Value added (constant 2005 US$) of Jamaica in 2006 to that in 2009?
Provide a short and direct response. 1.02. What is the ratio of the Value added (constant 2005 US$) of Seychelles in 2006 to that in 2009?
Your answer should be compact. 1.14. What is the ratio of the Value added (constant 2005 US$) of Togo in 2006 to that in 2009?
Provide a succinct answer. 1.14. What is the ratio of the Value added (constant 2005 US$) of Trinidad and Tobago in 2006 to that in 2009?
Provide a succinct answer. 1.13. What is the ratio of the Value added (constant 2005 US$) of Jamaica in 2006 to that in 2010?
Provide a succinct answer. 1.02. What is the ratio of the Value added (constant 2005 US$) of Seychelles in 2006 to that in 2010?
Provide a succinct answer. 1.21. What is the ratio of the Value added (constant 2005 US$) of Togo in 2006 to that in 2010?
Give a very brief answer. 1.13. What is the ratio of the Value added (constant 2005 US$) of Trinidad and Tobago in 2006 to that in 2010?
Keep it short and to the point. 0.64. What is the ratio of the Value added (constant 2005 US$) of Jamaica in 2006 to that in 2011?
Your answer should be compact. 0.92. What is the ratio of the Value added (constant 2005 US$) of Seychelles in 2006 to that in 2011?
Ensure brevity in your answer.  1.17. What is the ratio of the Value added (constant 2005 US$) of Togo in 2006 to that in 2011?
Give a very brief answer. 1.07. What is the ratio of the Value added (constant 2005 US$) of Trinidad and Tobago in 2006 to that in 2011?
Provide a short and direct response. 0.64. What is the ratio of the Value added (constant 2005 US$) of Jamaica in 2006 to that in 2012?
Keep it short and to the point. 0.9. What is the ratio of the Value added (constant 2005 US$) in Seychelles in 2006 to that in 2012?
Keep it short and to the point. 1.18. What is the ratio of the Value added (constant 2005 US$) of Togo in 2006 to that in 2012?
Your answer should be compact. 0.98. What is the ratio of the Value added (constant 2005 US$) in Trinidad and Tobago in 2006 to that in 2012?
Your response must be concise. 0.79. What is the ratio of the Value added (constant 2005 US$) in Jamaica in 2007 to that in 2008?
Your response must be concise. 1.07. What is the ratio of the Value added (constant 2005 US$) in Seychelles in 2007 to that in 2008?
Keep it short and to the point. 0.96. What is the ratio of the Value added (constant 2005 US$) in Togo in 2007 to that in 2008?
Your answer should be compact. 0.86. What is the ratio of the Value added (constant 2005 US$) of Trinidad and Tobago in 2007 to that in 2008?
Keep it short and to the point. 0.93. What is the ratio of the Value added (constant 2005 US$) in Jamaica in 2007 to that in 2009?
Make the answer very short. 0.94. What is the ratio of the Value added (constant 2005 US$) in Seychelles in 2007 to that in 2009?
Your response must be concise. 1.14. What is the ratio of the Value added (constant 2005 US$) in Togo in 2007 to that in 2009?
Make the answer very short. 1.17. What is the ratio of the Value added (constant 2005 US$) of Trinidad and Tobago in 2007 to that in 2009?
Give a very brief answer. 1.38. What is the ratio of the Value added (constant 2005 US$) of Jamaica in 2007 to that in 2010?
Make the answer very short. 0.93. What is the ratio of the Value added (constant 2005 US$) of Seychelles in 2007 to that in 2010?
Keep it short and to the point. 1.22. What is the ratio of the Value added (constant 2005 US$) of Togo in 2007 to that in 2010?
Offer a terse response. 1.15. What is the ratio of the Value added (constant 2005 US$) in Jamaica in 2007 to that in 2011?
Your response must be concise. 0.85. What is the ratio of the Value added (constant 2005 US$) of Seychelles in 2007 to that in 2011?
Your answer should be very brief. 1.18. What is the ratio of the Value added (constant 2005 US$) of Togo in 2007 to that in 2011?
Make the answer very short. 1.1. What is the ratio of the Value added (constant 2005 US$) of Trinidad and Tobago in 2007 to that in 2011?
Ensure brevity in your answer.  0.78. What is the ratio of the Value added (constant 2005 US$) in Jamaica in 2007 to that in 2012?
Provide a short and direct response. 0.83. What is the ratio of the Value added (constant 2005 US$) in Seychelles in 2007 to that in 2012?
Keep it short and to the point. 1.19. What is the ratio of the Value added (constant 2005 US$) in Trinidad and Tobago in 2007 to that in 2012?
Ensure brevity in your answer.  0.96. What is the ratio of the Value added (constant 2005 US$) of Jamaica in 2008 to that in 2009?
Give a very brief answer. 0.88. What is the ratio of the Value added (constant 2005 US$) of Seychelles in 2008 to that in 2009?
Ensure brevity in your answer.  1.2. What is the ratio of the Value added (constant 2005 US$) of Togo in 2008 to that in 2009?
Offer a terse response. 1.36. What is the ratio of the Value added (constant 2005 US$) in Trinidad and Tobago in 2008 to that in 2009?
Your answer should be very brief. 1.48. What is the ratio of the Value added (constant 2005 US$) in Jamaica in 2008 to that in 2010?
Provide a succinct answer. 0.88. What is the ratio of the Value added (constant 2005 US$) of Seychelles in 2008 to that in 2010?
Keep it short and to the point. 1.28. What is the ratio of the Value added (constant 2005 US$) of Togo in 2008 to that in 2010?
Keep it short and to the point. 1.34. What is the ratio of the Value added (constant 2005 US$) of Trinidad and Tobago in 2008 to that in 2010?
Your response must be concise. 0.84. What is the ratio of the Value added (constant 2005 US$) in Jamaica in 2008 to that in 2011?
Give a very brief answer. 0.8. What is the ratio of the Value added (constant 2005 US$) of Seychelles in 2008 to that in 2011?
Offer a terse response. 1.23. What is the ratio of the Value added (constant 2005 US$) of Togo in 2008 to that in 2011?
Your response must be concise. 1.28. What is the ratio of the Value added (constant 2005 US$) of Trinidad and Tobago in 2008 to that in 2011?
Your answer should be compact. 0.84. What is the ratio of the Value added (constant 2005 US$) of Jamaica in 2008 to that in 2012?
Offer a very short reply. 0.78. What is the ratio of the Value added (constant 2005 US$) of Seychelles in 2008 to that in 2012?
Offer a terse response. 1.25. What is the ratio of the Value added (constant 2005 US$) in Togo in 2008 to that in 2012?
Offer a very short reply. 1.16. What is the ratio of the Value added (constant 2005 US$) in Trinidad and Tobago in 2008 to that in 2012?
Make the answer very short. 1.04. What is the ratio of the Value added (constant 2005 US$) of Seychelles in 2009 to that in 2010?
Give a very brief answer. 1.07. What is the ratio of the Value added (constant 2005 US$) in Togo in 2009 to that in 2010?
Ensure brevity in your answer.  0.99. What is the ratio of the Value added (constant 2005 US$) of Trinidad and Tobago in 2009 to that in 2010?
Your response must be concise. 0.57. What is the ratio of the Value added (constant 2005 US$) in Jamaica in 2009 to that in 2011?
Offer a very short reply. 0.91. What is the ratio of the Value added (constant 2005 US$) of Seychelles in 2009 to that in 2011?
Make the answer very short. 1.03. What is the ratio of the Value added (constant 2005 US$) in Togo in 2009 to that in 2011?
Offer a very short reply. 0.94. What is the ratio of the Value added (constant 2005 US$) in Trinidad and Tobago in 2009 to that in 2011?
Ensure brevity in your answer.  0.57. What is the ratio of the Value added (constant 2005 US$) of Jamaica in 2009 to that in 2012?
Provide a short and direct response. 0.89. What is the ratio of the Value added (constant 2005 US$) in Seychelles in 2009 to that in 2012?
Your response must be concise. 1.04. What is the ratio of the Value added (constant 2005 US$) of Togo in 2009 to that in 2012?
Your response must be concise. 0.85. What is the ratio of the Value added (constant 2005 US$) of Trinidad and Tobago in 2009 to that in 2012?
Offer a terse response. 0.7. What is the ratio of the Value added (constant 2005 US$) in Jamaica in 2010 to that in 2011?
Your answer should be compact. 0.91. What is the ratio of the Value added (constant 2005 US$) in Seychelles in 2010 to that in 2011?
Give a very brief answer. 0.97. What is the ratio of the Value added (constant 2005 US$) of Togo in 2010 to that in 2011?
Keep it short and to the point. 0.95. What is the ratio of the Value added (constant 2005 US$) in Jamaica in 2010 to that in 2012?
Offer a terse response. 0.89. What is the ratio of the Value added (constant 2005 US$) of Seychelles in 2010 to that in 2012?
Your response must be concise. 0.98. What is the ratio of the Value added (constant 2005 US$) in Togo in 2010 to that in 2012?
Give a very brief answer. 0.87. What is the ratio of the Value added (constant 2005 US$) of Trinidad and Tobago in 2010 to that in 2012?
Make the answer very short. 1.24. What is the ratio of the Value added (constant 2005 US$) of Jamaica in 2011 to that in 2012?
Provide a succinct answer. 0.98. What is the ratio of the Value added (constant 2005 US$) of Seychelles in 2011 to that in 2012?
Keep it short and to the point. 1.01. What is the ratio of the Value added (constant 2005 US$) of Togo in 2011 to that in 2012?
Keep it short and to the point. 0.91. What is the ratio of the Value added (constant 2005 US$) of Trinidad and Tobago in 2011 to that in 2012?
Your answer should be compact. 1.24. What is the difference between the highest and the second highest Value added (constant 2005 US$) in Jamaica?
Ensure brevity in your answer.  1.76e+07. What is the difference between the highest and the second highest Value added (constant 2005 US$) of Seychelles?
Keep it short and to the point. 1.33e+06. What is the difference between the highest and the second highest Value added (constant 2005 US$) in Togo?
Offer a terse response. 1.29e+08. What is the difference between the highest and the second highest Value added (constant 2005 US$) of Trinidad and Tobago?
Your answer should be compact. 1.78e+05. What is the difference between the highest and the lowest Value added (constant 2005 US$) of Jamaica?
Offer a terse response. 1.72e+08. What is the difference between the highest and the lowest Value added (constant 2005 US$) in Seychelles?
Your answer should be compact. 6.48e+06. What is the difference between the highest and the lowest Value added (constant 2005 US$) of Togo?
Make the answer very short. 2.48e+08. What is the difference between the highest and the lowest Value added (constant 2005 US$) of Trinidad and Tobago?
Provide a succinct answer. 4.74e+07. 